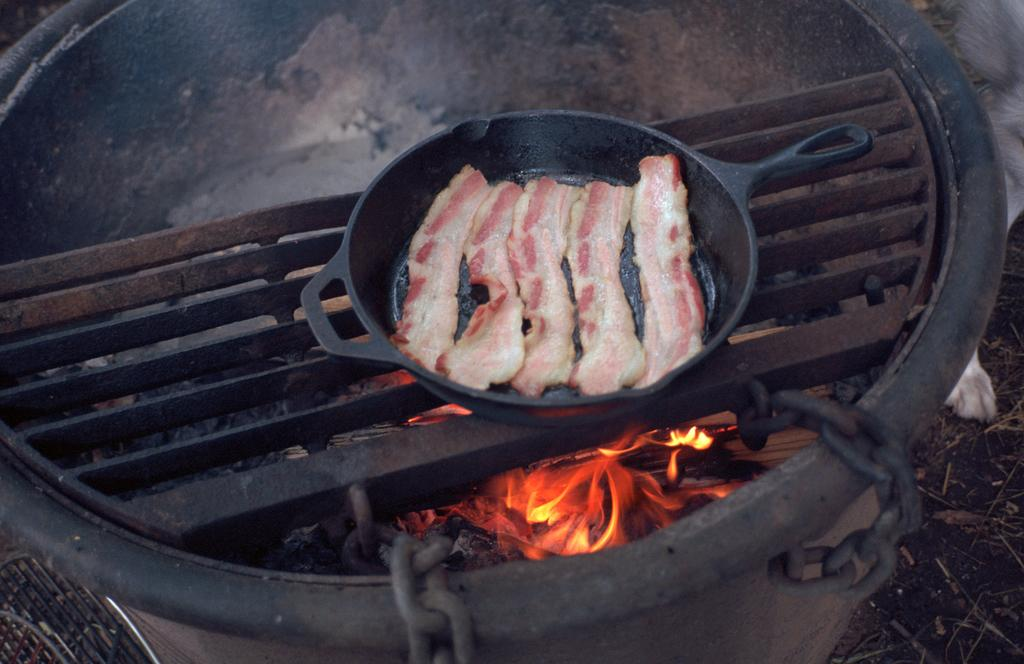What is present in the image? There is food in the image. How is the food being prepared? The food is on the fire. What type of shoes can be seen on the fire in the image? There are no shoes present in the image; it features a food item on the fire. 